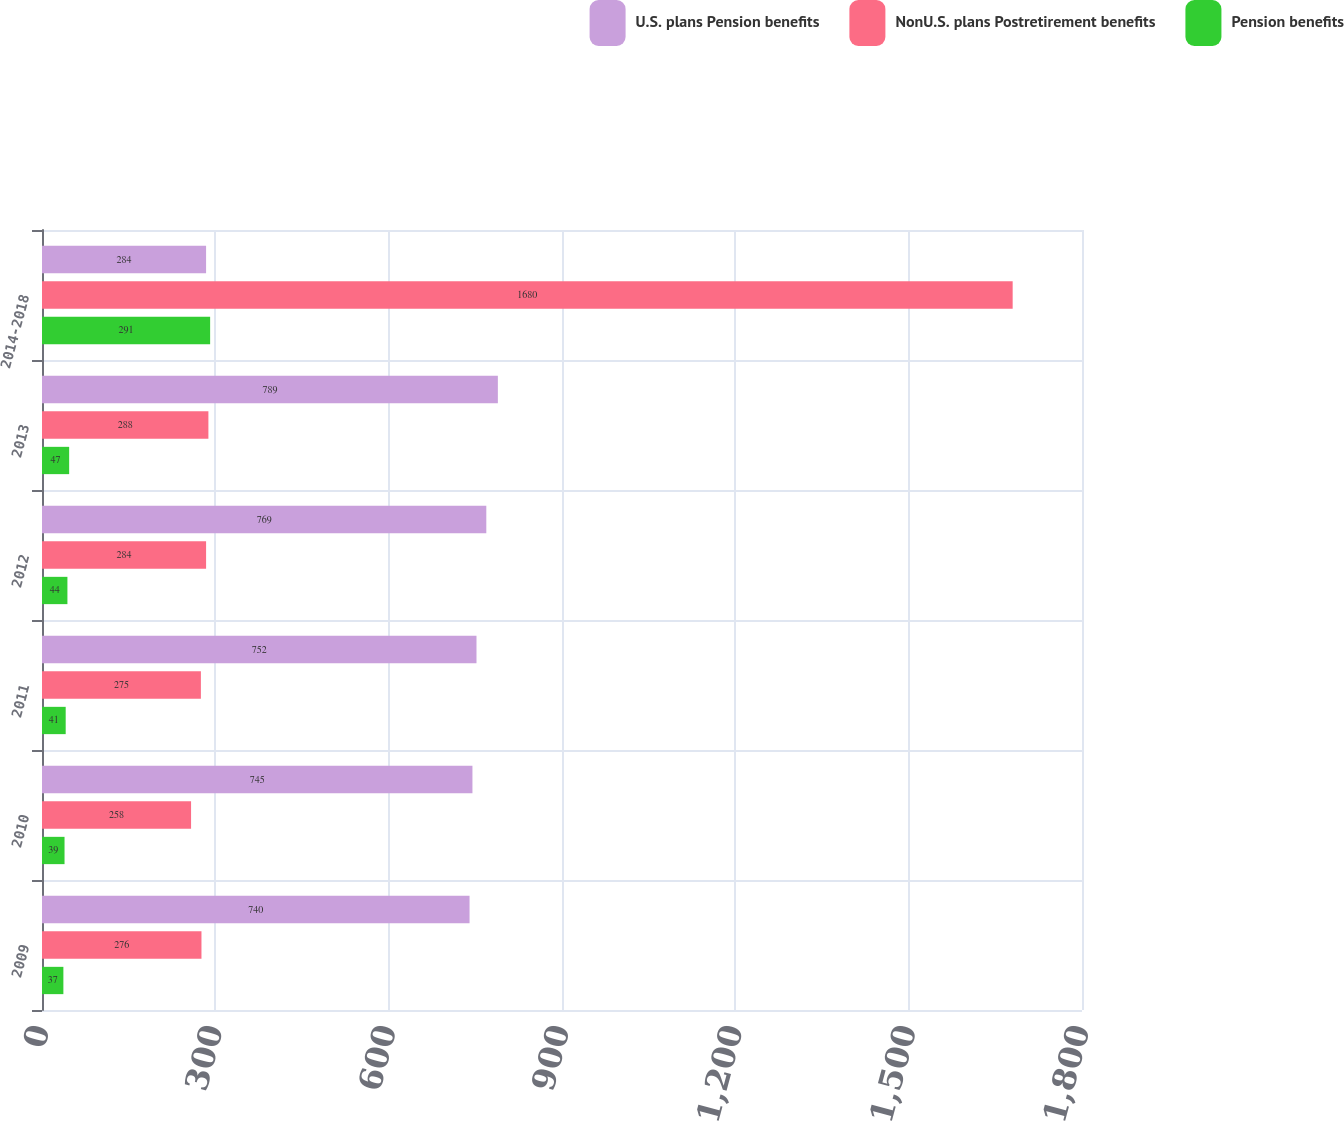Convert chart. <chart><loc_0><loc_0><loc_500><loc_500><stacked_bar_chart><ecel><fcel>2009<fcel>2010<fcel>2011<fcel>2012<fcel>2013<fcel>2014-2018<nl><fcel>U.S. plans Pension benefits<fcel>740<fcel>745<fcel>752<fcel>769<fcel>789<fcel>284<nl><fcel>NonU.S. plans Postretirement benefits<fcel>276<fcel>258<fcel>275<fcel>284<fcel>288<fcel>1680<nl><fcel>Pension benefits<fcel>37<fcel>39<fcel>41<fcel>44<fcel>47<fcel>291<nl></chart> 